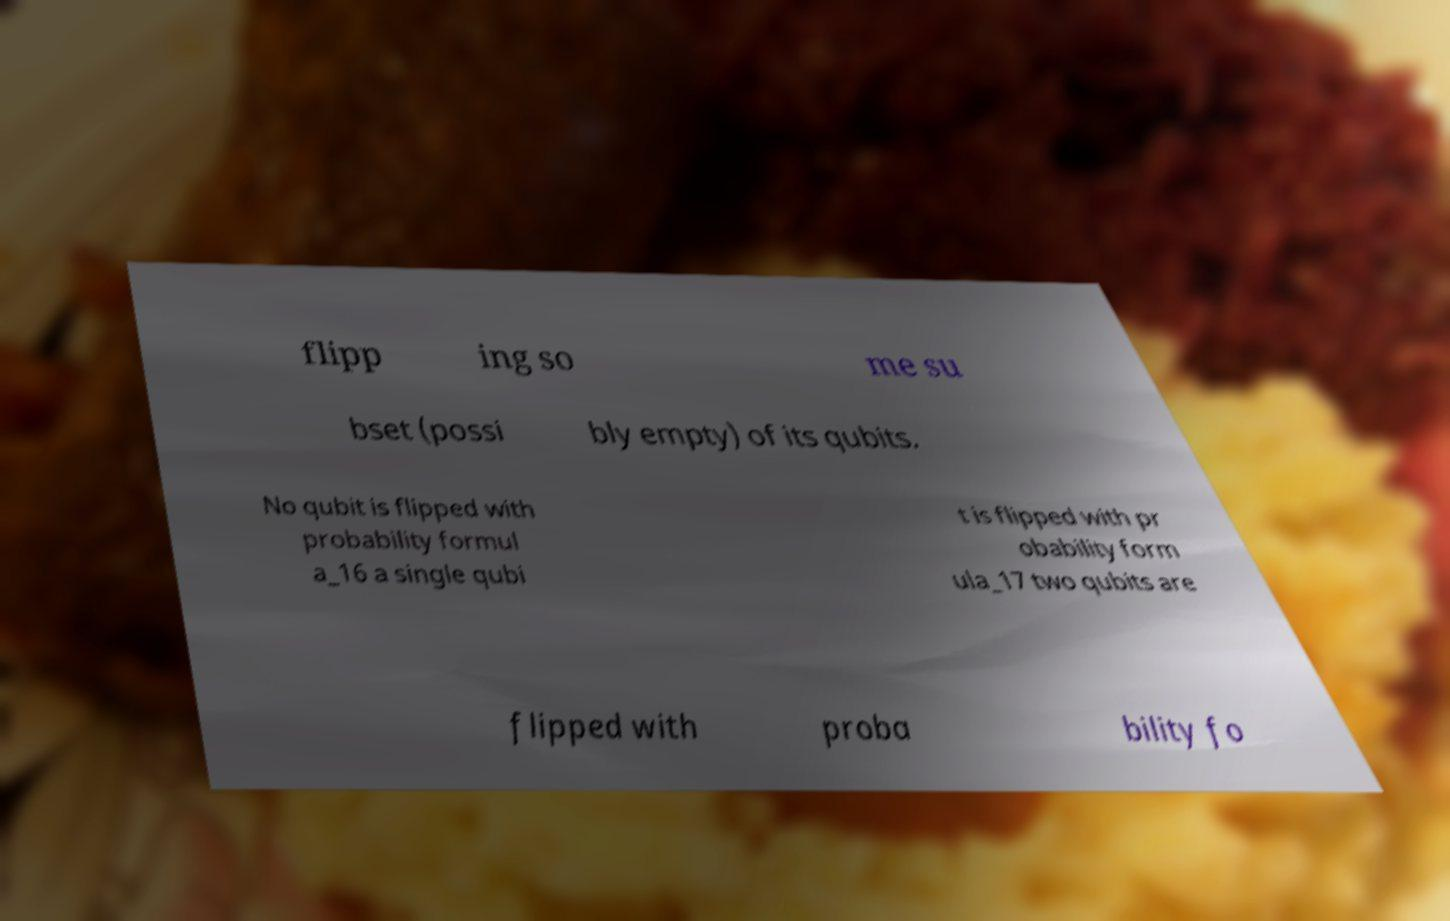Can you accurately transcribe the text from the provided image for me? flipp ing so me su bset (possi bly empty) of its qubits. No qubit is flipped with probability formul a_16 a single qubi t is flipped with pr obability form ula_17 two qubits are flipped with proba bility fo 